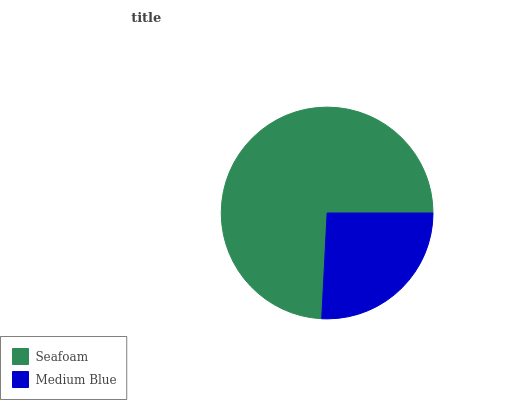Is Medium Blue the minimum?
Answer yes or no. Yes. Is Seafoam the maximum?
Answer yes or no. Yes. Is Medium Blue the maximum?
Answer yes or no. No. Is Seafoam greater than Medium Blue?
Answer yes or no. Yes. Is Medium Blue less than Seafoam?
Answer yes or no. Yes. Is Medium Blue greater than Seafoam?
Answer yes or no. No. Is Seafoam less than Medium Blue?
Answer yes or no. No. Is Seafoam the high median?
Answer yes or no. Yes. Is Medium Blue the low median?
Answer yes or no. Yes. Is Medium Blue the high median?
Answer yes or no. No. Is Seafoam the low median?
Answer yes or no. No. 